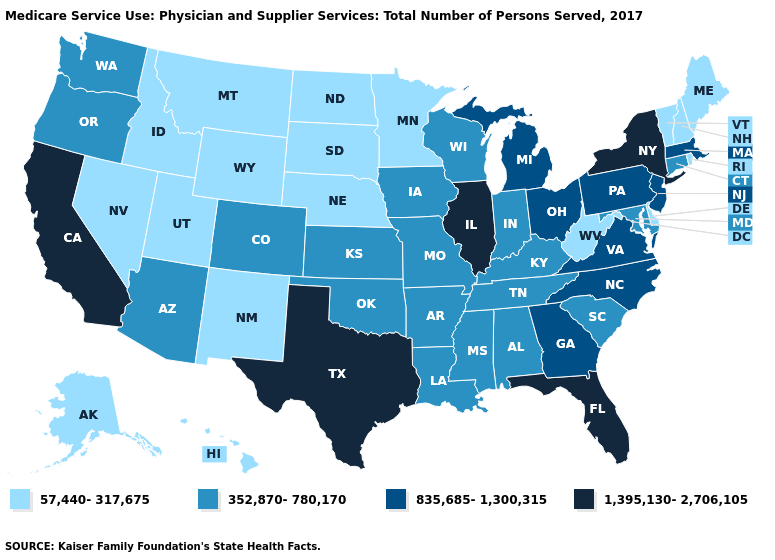Does Alabama have a lower value than North Carolina?
Give a very brief answer. Yes. Does Illinois have the highest value in the USA?
Be succinct. Yes. Name the states that have a value in the range 57,440-317,675?
Keep it brief. Alaska, Delaware, Hawaii, Idaho, Maine, Minnesota, Montana, Nebraska, Nevada, New Hampshire, New Mexico, North Dakota, Rhode Island, South Dakota, Utah, Vermont, West Virginia, Wyoming. Among the states that border North Carolina , which have the highest value?
Be succinct. Georgia, Virginia. What is the value of Mississippi?
Keep it brief. 352,870-780,170. Is the legend a continuous bar?
Short answer required. No. Does Mississippi have a higher value than Nebraska?
Keep it brief. Yes. Name the states that have a value in the range 57,440-317,675?
Give a very brief answer. Alaska, Delaware, Hawaii, Idaho, Maine, Minnesota, Montana, Nebraska, Nevada, New Hampshire, New Mexico, North Dakota, Rhode Island, South Dakota, Utah, Vermont, West Virginia, Wyoming. Among the states that border Texas , does Arkansas have the highest value?
Concise answer only. Yes. Name the states that have a value in the range 57,440-317,675?
Quick response, please. Alaska, Delaware, Hawaii, Idaho, Maine, Minnesota, Montana, Nebraska, Nevada, New Hampshire, New Mexico, North Dakota, Rhode Island, South Dakota, Utah, Vermont, West Virginia, Wyoming. Among the states that border Vermont , does New Hampshire have the lowest value?
Write a very short answer. Yes. Name the states that have a value in the range 1,395,130-2,706,105?
Write a very short answer. California, Florida, Illinois, New York, Texas. What is the value of Florida?
Concise answer only. 1,395,130-2,706,105. Name the states that have a value in the range 57,440-317,675?
Be succinct. Alaska, Delaware, Hawaii, Idaho, Maine, Minnesota, Montana, Nebraska, Nevada, New Hampshire, New Mexico, North Dakota, Rhode Island, South Dakota, Utah, Vermont, West Virginia, Wyoming. Does Hawaii have the lowest value in the USA?
Concise answer only. Yes. 